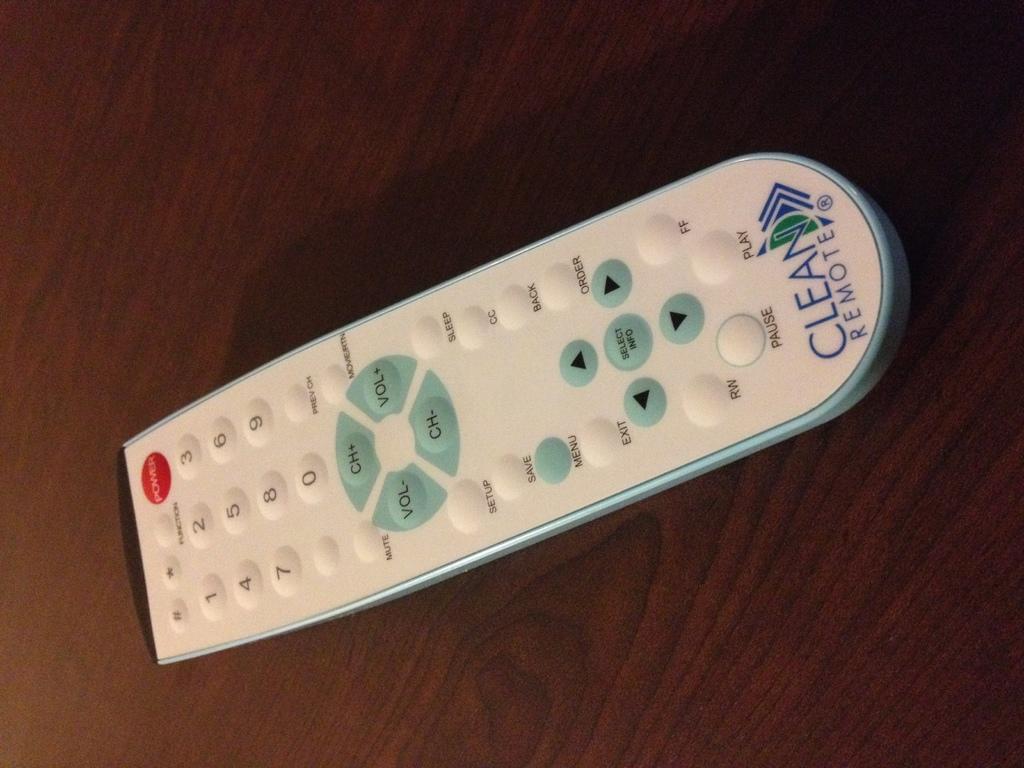What brand is this remote control?
Ensure brevity in your answer.  Clean remote. What button is to the left of the "play" button?
Offer a very short reply. Pause. 